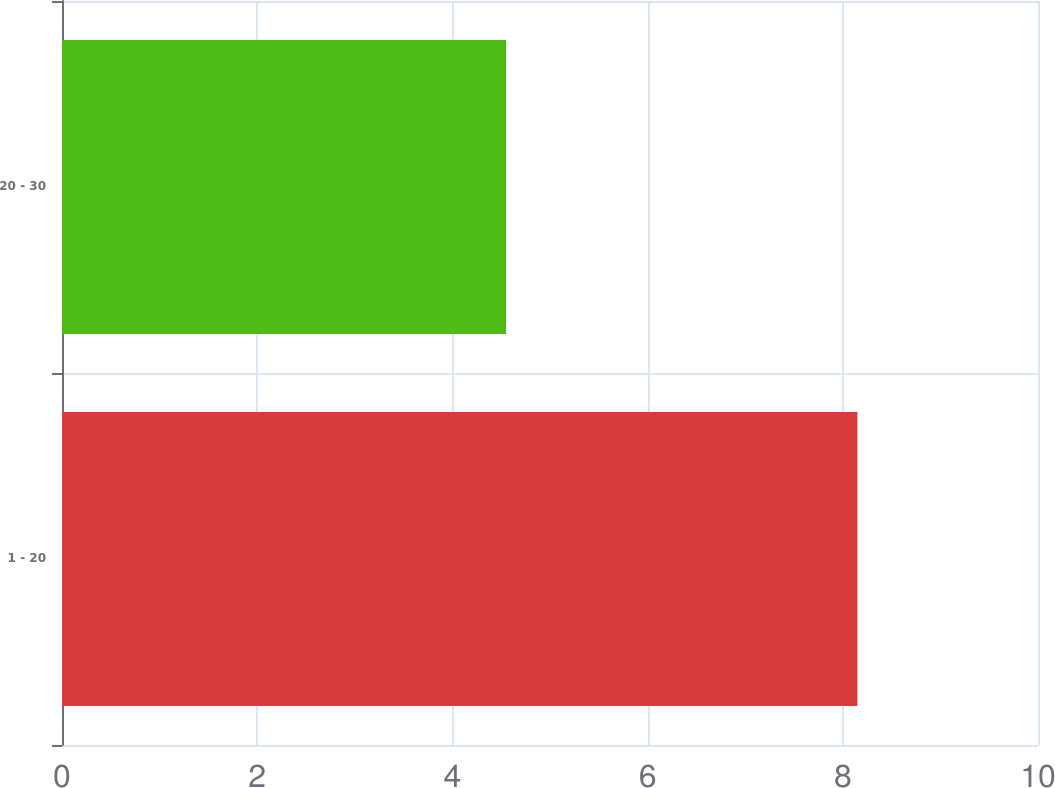<chart> <loc_0><loc_0><loc_500><loc_500><bar_chart><fcel>1 - 20<fcel>20 - 30<nl><fcel>8.15<fcel>4.55<nl></chart> 